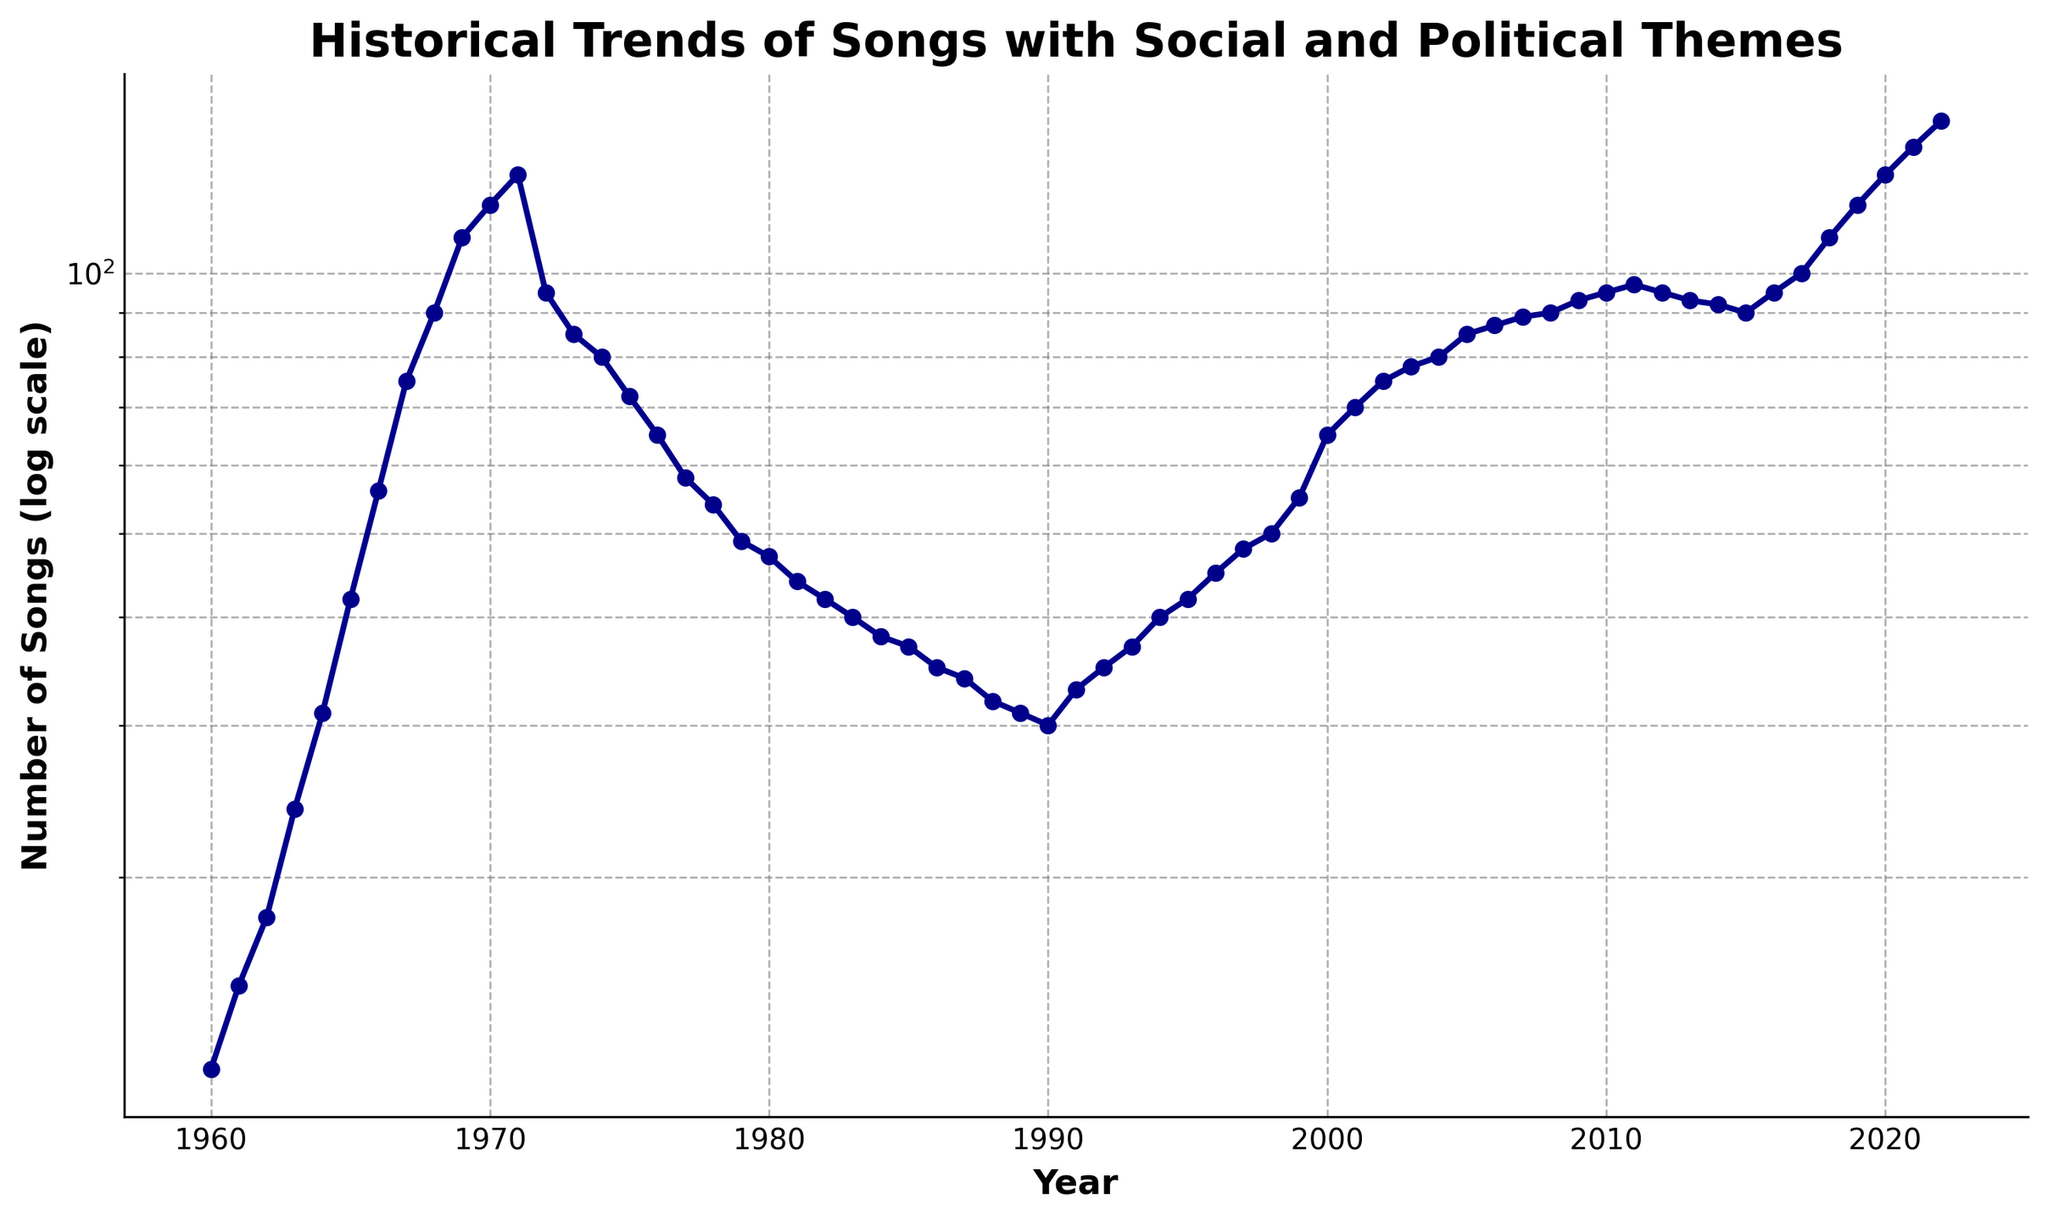What is the number of songs with social and political themes in the year 1970? The figure shows a logscale chart indicating the trend of the number of songs per year. By locating the year 1970 on the x-axis, we can find the corresponding value on the y-axis, which is 120.
Answer: 120 How does the number of songs with social and political themes in 2020 compare to 1969? To compare, we look at the values for both years on the y-axis. In 1969, the number of songs is 110, and in 2020, it is 130. Hence, the number of songs in 2020 is higher than in 1969.
Answer: Higher What is the percentage increase in the number of songs from 1960 to 1969? First, find the values for 1960 and 1969, which are 12 and 110 respectively. The increase is 110 - 12 = 98. The percentage increase is (98 / 12) * 100 = 816.67%.
Answer: 816.67% What period saw the greatest decline in the number of songs, and by how much? From the figure, the greatest decline occurred from 1971 (130 songs) to 1972 (95 songs). The decline is 130 - 95 = 35 songs.
Answer: 1971 to 1972, 35 songs Which year has the highest number of songs with social and political themes, and what is that number? By looking at the peak in the figure, the highest number of songs occurs in 2022 with 150 songs.
Answer: 2022, 150 During which decade did the number of songs with social and political themes increase the most overall? Compare the number of songs at the beginning and the end of each decade. The greatest increase is from the 1960s (1960: 12, 1969: 110) with an increase of 110 - 12 = 98 songs.
Answer: 1960s How did the trend change after the year 2000 compared to the 1990s? The 1990s show a fluctuating but generally increasing trend, while post-2000 sees a clearer and more consistent upward trend. For example, the numbers increase from 55 in 1999 to 150 in 2022.
Answer: Clearer upward trend post-2000 